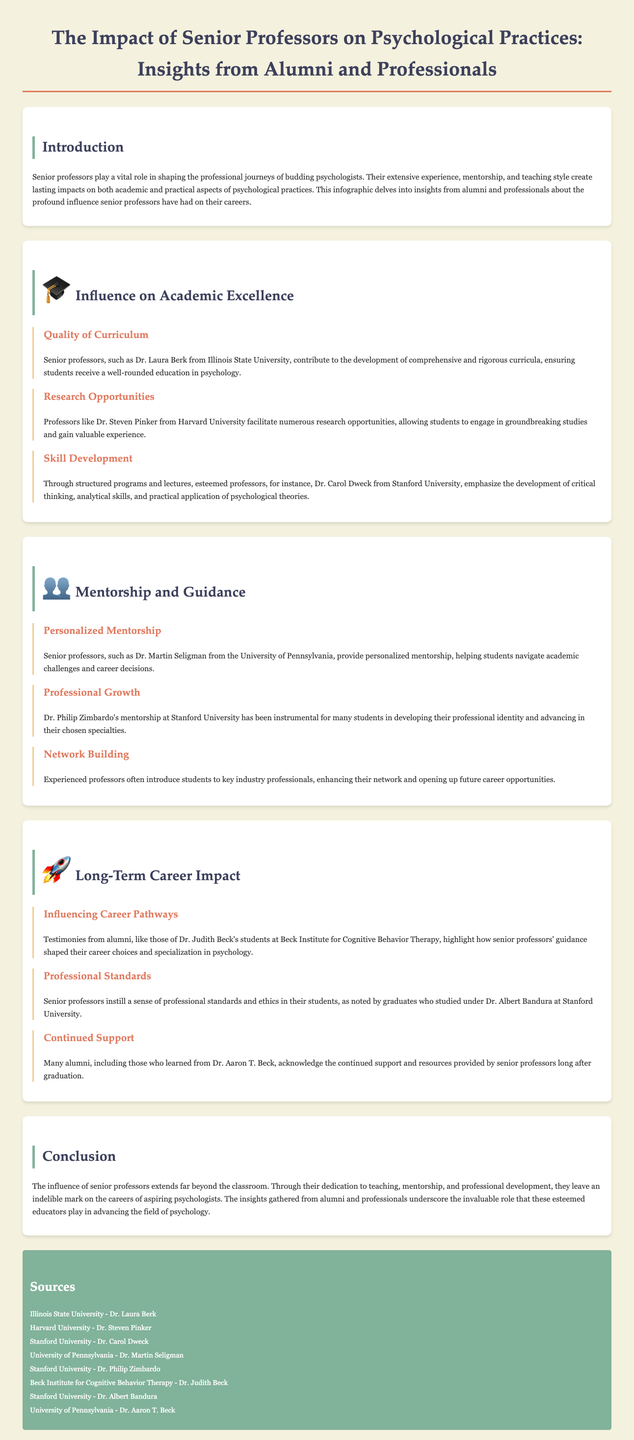What is the main focus of the infographic? The infographic focuses on the impact of senior professors on psychological practices through insights from alumni and professionals.
Answer: The impact of senior professors on psychological practices Who is highlighted as contributing to the quality of curriculum? Dr. Laura Berk from Illinois State University is mentioned for her contributions to the development of comprehensive curricula.
Answer: Dr. Laura Berk Which professor provides personalized mentorship? The document states that Dr. Martin Seligman from the University of Pennsylvania provides personalized mentorship.
Answer: Dr. Martin Seligman How do senior professors impact career pathways? Alumni testimonies show that senior professors' guidance significantly shapes students' career choices and specializations in psychology.
Answer: Career choices and specialization Which university is associated with Dr. Carol Dweck? Dr. Carol Dweck is associated with Stanford University, focusing on skill development.
Answer: Stanford University What is mentioned as a benefit of mentorship by senior professors? Mentorship from senior professors enhances network building for their students.
Answer: Network building What aspect of professional standards do senior professors instill? Senior professors instill a sense of professional standards and ethics in their students.
Answer: Professional standards and ethics How does the infographic describe the long-term support from professors? Many alumni acknowledge the continued support provided by senior professors long after graduation.
Answer: Continued support 